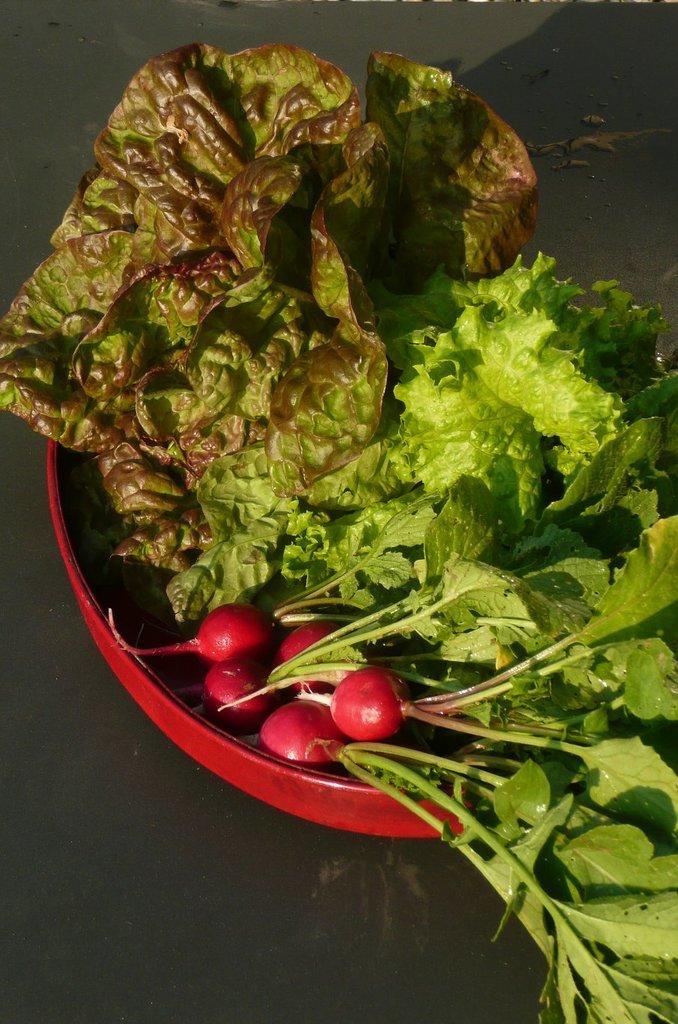Could you give a brief overview of what you see in this image? In this image we can see a bowl. Inside the bowl we can see turnips and few leafy vegetables. 